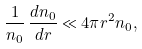Convert formula to latex. <formula><loc_0><loc_0><loc_500><loc_500>\frac { 1 } { n _ { 0 } } \, \frac { d n _ { 0 } } { d r } \ll 4 \pi r ^ { 2 } n _ { 0 } ,</formula> 